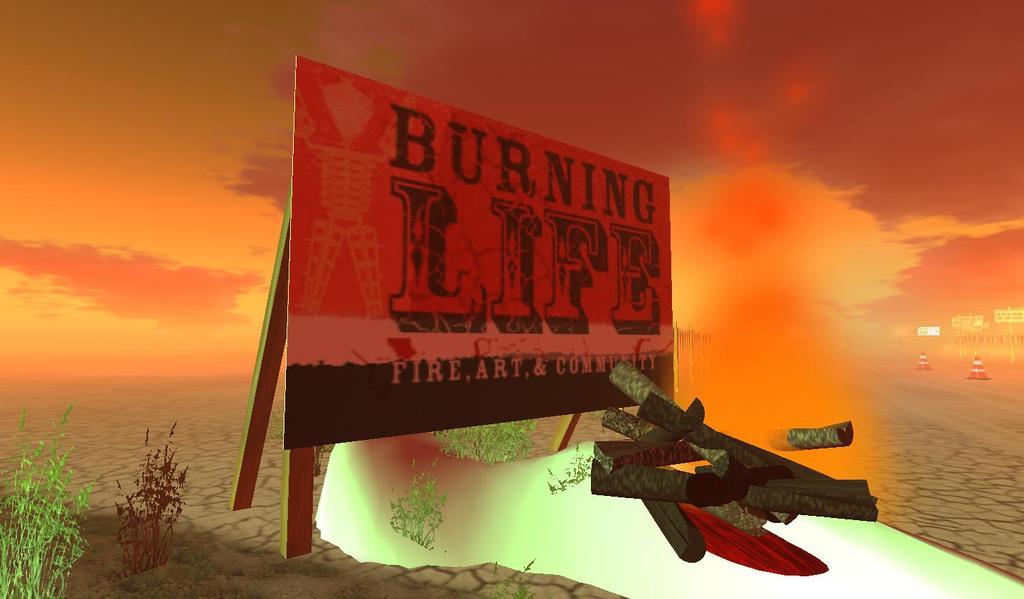What does the billboard say?
Keep it short and to the point. Burning life. 